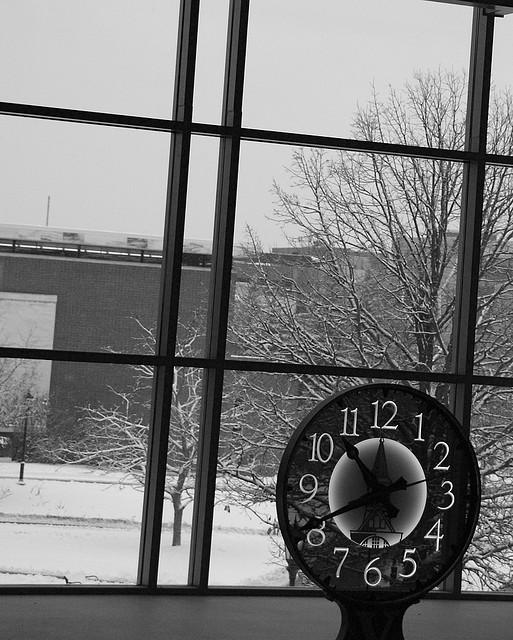Is the clock opaque or transparent?
Give a very brief answer. Opaque. Is this a color photo?
Answer briefly. No. What season is this?
Write a very short answer. Winter. 